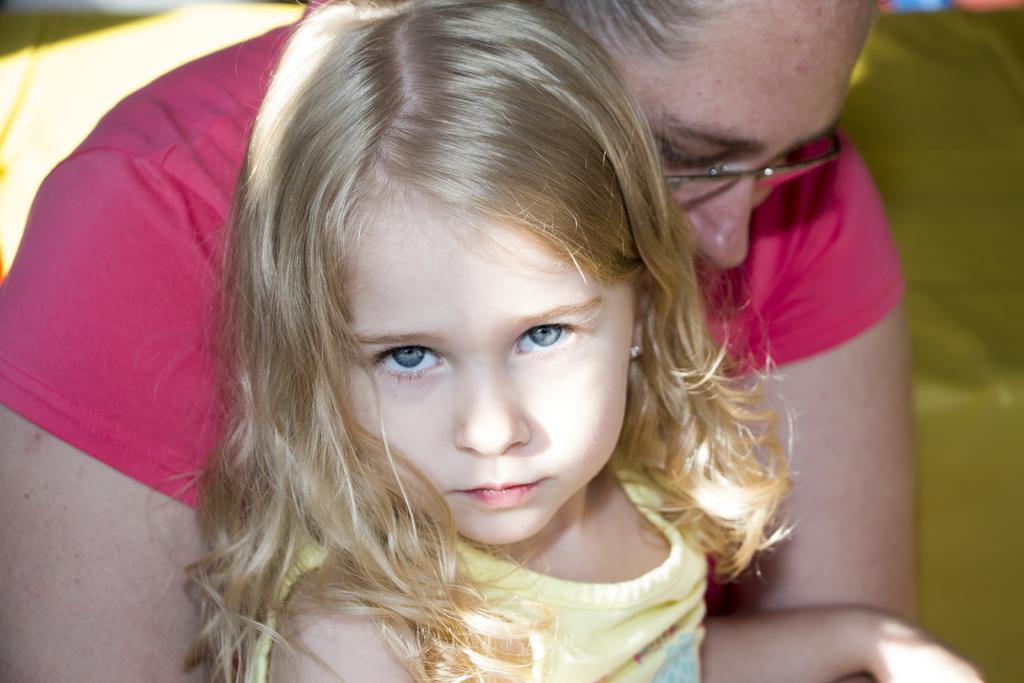Please provide a concise description of this image. In this picture we can see a girl and a woman. There is a green color object in the background. 